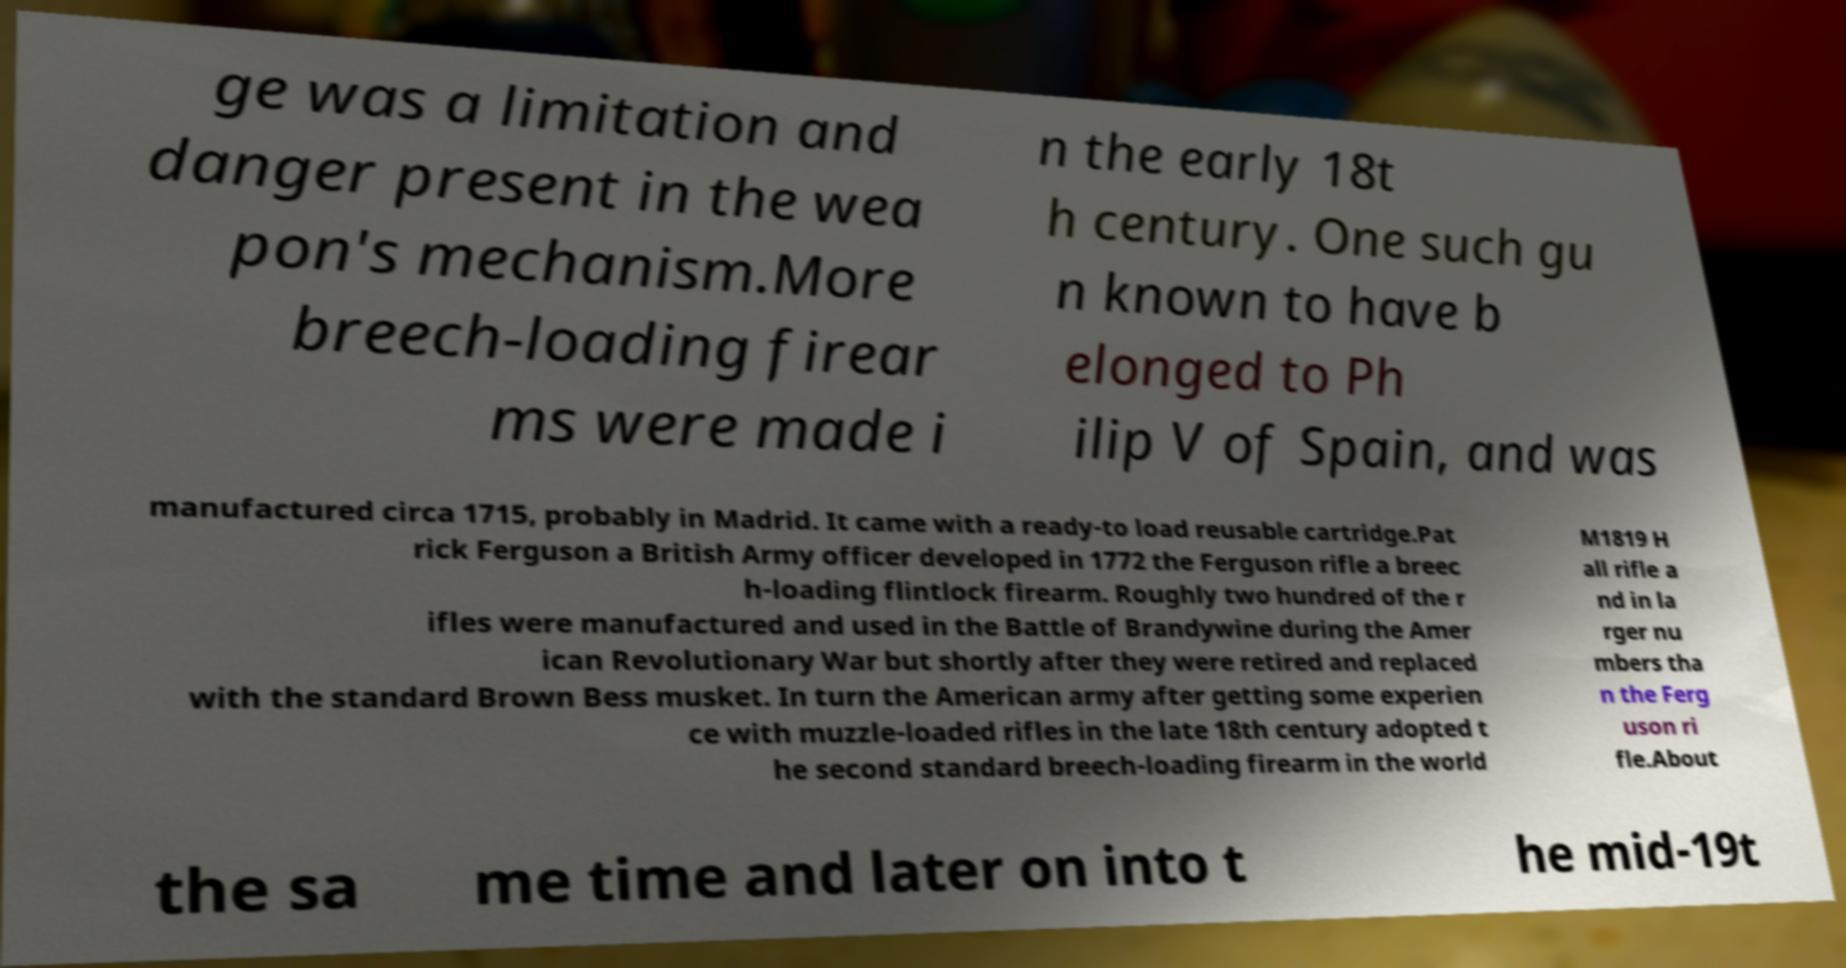Can you read and provide the text displayed in the image?This photo seems to have some interesting text. Can you extract and type it out for me? ge was a limitation and danger present in the wea pon's mechanism.More breech-loading firear ms were made i n the early 18t h century. One such gu n known to have b elonged to Ph ilip V of Spain, and was manufactured circa 1715, probably in Madrid. It came with a ready-to load reusable cartridge.Pat rick Ferguson a British Army officer developed in 1772 the Ferguson rifle a breec h-loading flintlock firearm. Roughly two hundred of the r ifles were manufactured and used in the Battle of Brandywine during the Amer ican Revolutionary War but shortly after they were retired and replaced with the standard Brown Bess musket. In turn the American army after getting some experien ce with muzzle-loaded rifles in the late 18th century adopted t he second standard breech-loading firearm in the world M1819 H all rifle a nd in la rger nu mbers tha n the Ferg uson ri fle.About the sa me time and later on into t he mid-19t 